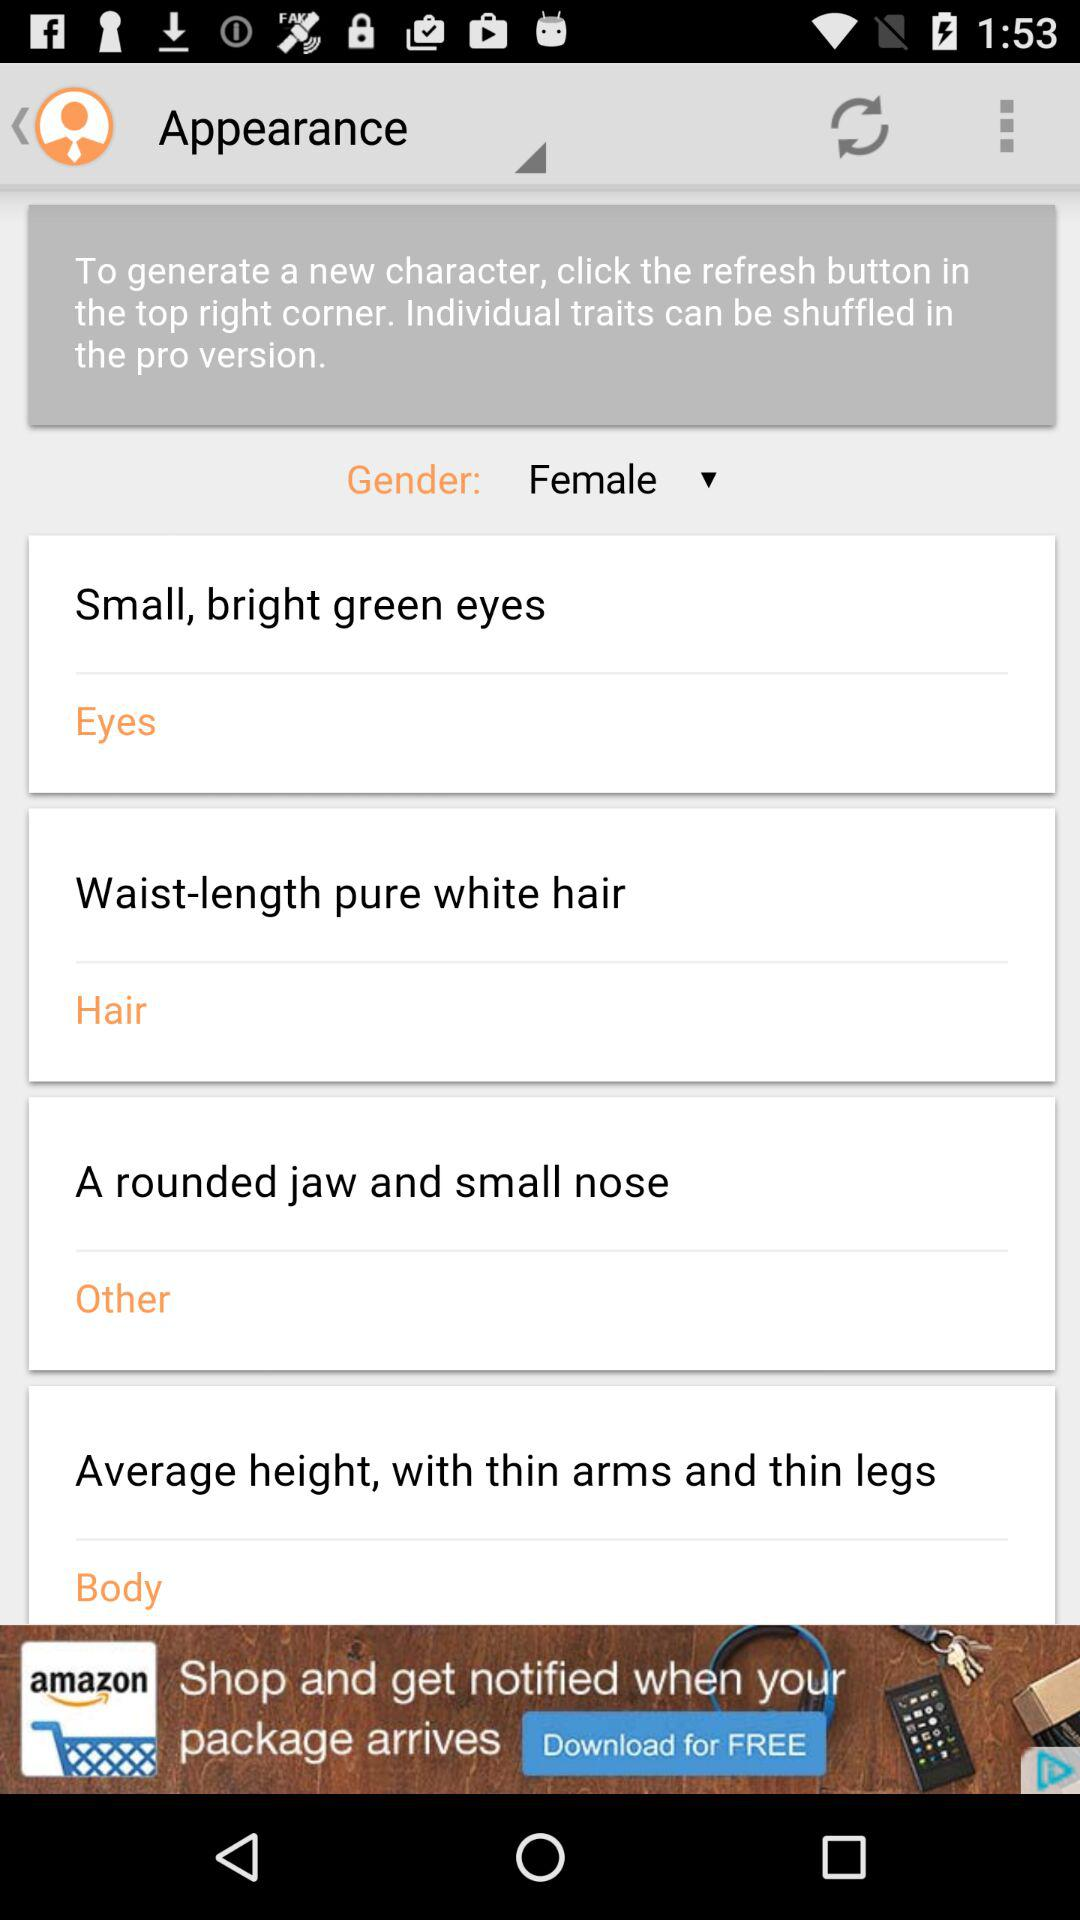What is the length of the hair? The hair is waist-length. 